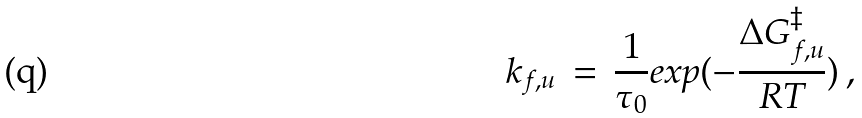Convert formula to latex. <formula><loc_0><loc_0><loc_500><loc_500>k _ { f , u } \, = \, \frac { 1 } { \tau _ { 0 } } e x p ( - \frac { \Delta G _ { f , u } ^ { \ddagger } } { R T } ) \, ,</formula> 